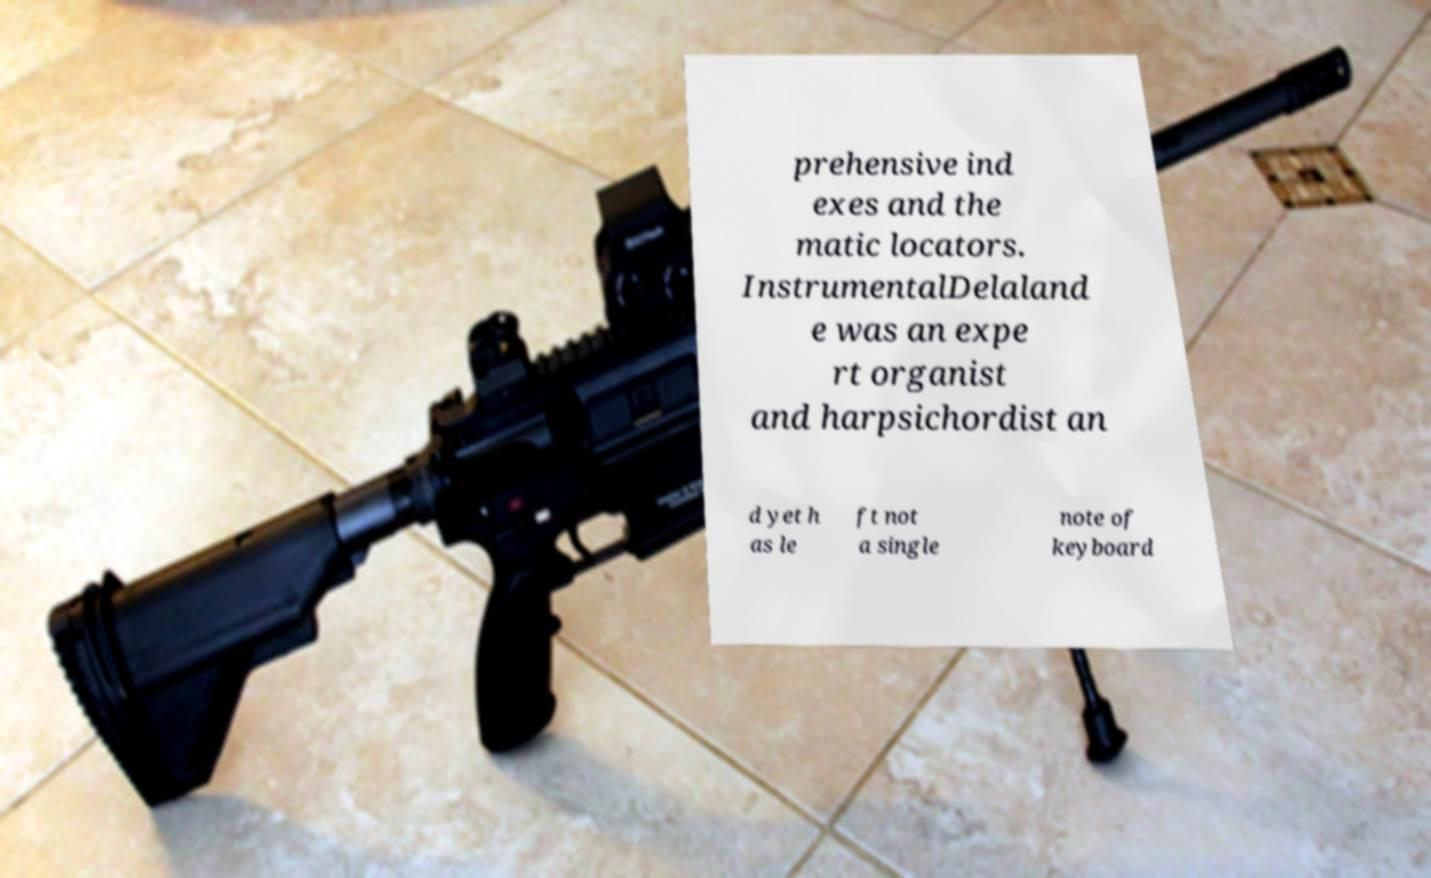Could you extract and type out the text from this image? prehensive ind exes and the matic locators. InstrumentalDelaland e was an expe rt organist and harpsichordist an d yet h as le ft not a single note of keyboard 